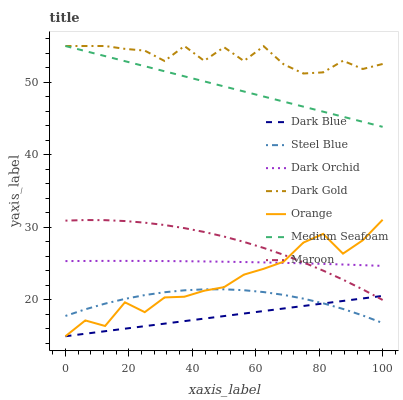Does Steel Blue have the minimum area under the curve?
Answer yes or no. No. Does Steel Blue have the maximum area under the curve?
Answer yes or no. No. Is Steel Blue the smoothest?
Answer yes or no. No. Is Steel Blue the roughest?
Answer yes or no. No. Does Steel Blue have the lowest value?
Answer yes or no. No. Does Steel Blue have the highest value?
Answer yes or no. No. Is Dark Orchid less than Medium Seafoam?
Answer yes or no. Yes. Is Dark Gold greater than Maroon?
Answer yes or no. Yes. Does Dark Orchid intersect Medium Seafoam?
Answer yes or no. No. 